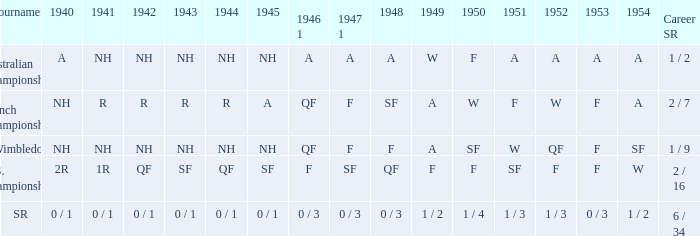What is the 1944 outcome for the u.s. championships? QF. 